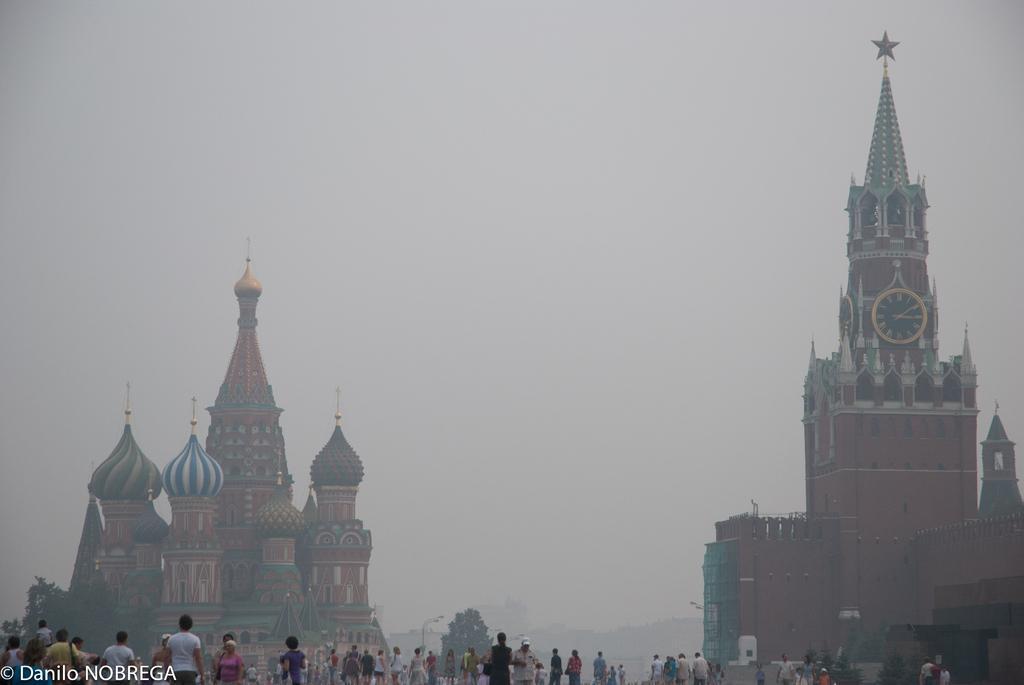Can you describe this image briefly? In this picture I can see group of people standing, there are poles, lights, trees, there is a soviet union cathedral, there is a building with clocks , and in the background there is sky and there is a watermark on the image. 